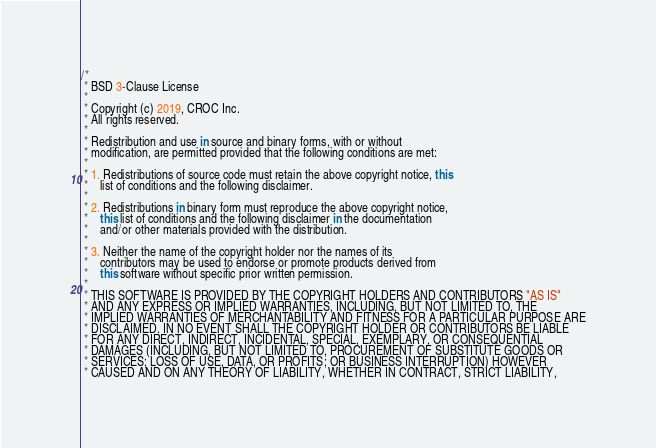<code> <loc_0><loc_0><loc_500><loc_500><_Kotlin_>/*
 * BSD 3-Clause License
 *
 * Copyright (c) 2019, CROC Inc.
 * All rights reserved.
 *
 * Redistribution and use in source and binary forms, with or without
 * modification, are permitted provided that the following conditions are met:
 *
 * 1. Redistributions of source code must retain the above copyright notice, this
 *    list of conditions and the following disclaimer.
 *
 * 2. Redistributions in binary form must reproduce the above copyright notice,
 *    this list of conditions and the following disclaimer in the documentation
 *    and/or other materials provided with the distribution.
 *
 * 3. Neither the name of the copyright holder nor the names of its
 *    contributors may be used to endorse or promote products derived from
 *    this software without specific prior written permission.
 *
 * THIS SOFTWARE IS PROVIDED BY THE COPYRIGHT HOLDERS AND CONTRIBUTORS "AS IS"
 * AND ANY EXPRESS OR IMPLIED WARRANTIES, INCLUDING, BUT NOT LIMITED TO, THE
 * IMPLIED WARRANTIES OF MERCHANTABILITY AND FITNESS FOR A PARTICULAR PURPOSE ARE
 * DISCLAIMED. IN NO EVENT SHALL THE COPYRIGHT HOLDER OR CONTRIBUTORS BE LIABLE
 * FOR ANY DIRECT, INDIRECT, INCIDENTAL, SPECIAL, EXEMPLARY, OR CONSEQUENTIAL
 * DAMAGES (INCLUDING, BUT NOT LIMITED TO, PROCUREMENT OF SUBSTITUTE GOODS OR
 * SERVICES; LOSS OF USE, DATA, OR PROFITS; OR BUSINESS INTERRUPTION) HOWEVER
 * CAUSED AND ON ANY THEORY OF LIABILITY, WHETHER IN CONTRACT, STRICT LIABILITY,</code> 